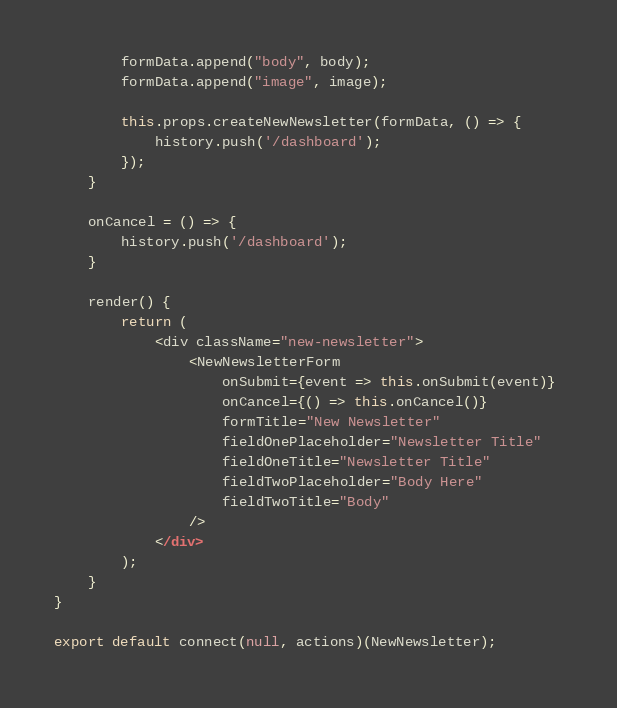<code> <loc_0><loc_0><loc_500><loc_500><_JavaScript_>        formData.append("body", body);
        formData.append("image", image);

        this.props.createNewNewsletter(formData, () => {
            history.push('/dashboard');
        });
    }

    onCancel = () => {
        history.push('/dashboard');
    }

    render() {
        return (
            <div className="new-newsletter">
                <NewNewsletterForm 
                    onSubmit={event => this.onSubmit(event)} 
                    onCancel={() => this.onCancel()} 
                    formTitle="New Newsletter"
                    fieldOnePlaceholder="Newsletter Title"
                    fieldOneTitle="Newsletter Title"
                    fieldTwoPlaceholder="Body Here"
                    fieldTwoTitle="Body"
                />
            </div>
        );
    }
}

export default connect(null, actions)(NewNewsletter);</code> 